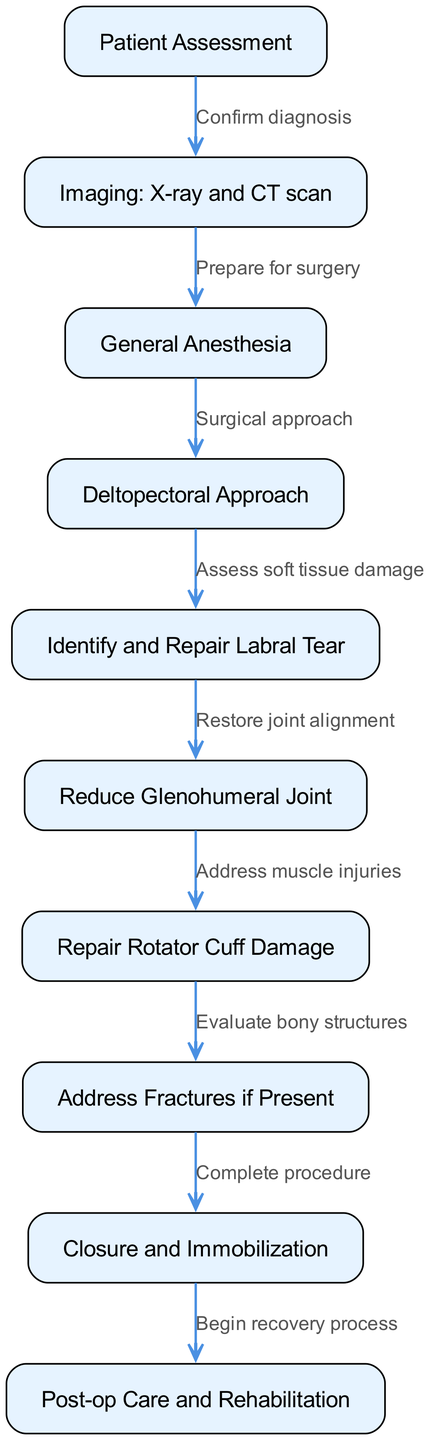What is the first step in the surgical intervention? The diagram starts with the "Patient Assessment" node, which is the first step in the surgical intervention process for a complex shoulder dislocation.
Answer: Patient Assessment How many nodes are there in the diagram? By counting each of the unique steps depicted in the diagram, there are a total of 10 nodes.
Answer: 10 Which step follows "Imaging: X-ray and CT scan"? Following the "Imaging: X-ray and CT scan," the next step in the process is "General Anesthesia." This is depicted directly in the edge leading from the imaging step.
Answer: General Anesthesia What action is taken after "Repair Rotator Cuff Damage"? After "Repair Rotator Cuff Damage," the process proceeds to "Address Fractures if Present," as shown by the connection between these nodes.
Answer: Address Fractures if Present What is the final step in the surgical process? The final step in the surgical intervention is "Post-op Care and Rehabilitation," which is indicated as the endpoint of the diagram.
Answer: Post-op Care and Rehabilitation What is the relationship between "Identify and Repair Labral Tear" and "Reduce Glenohumeral Joint"? The relationship is sequential, where "Identify and Repair Labral Tear" precedes "Reduce Glenohumeral Joint," indicating that labral repair needs to happen before joint reduction.
Answer: Sequential relationship How does the process begin after confirming the diagnosis? After confirming the diagnosis, the surgical intervention process moves to "Prepare for surgery" as indicated by the directed edge from the diagnosis node.
Answer: Prepare for surgery What step comes before "Closure and Immobilization"? The step before "Closure and Immobilization" is "Address Fractures if Present," based on the connections shown in the diagram.
Answer: Address Fractures if Present 